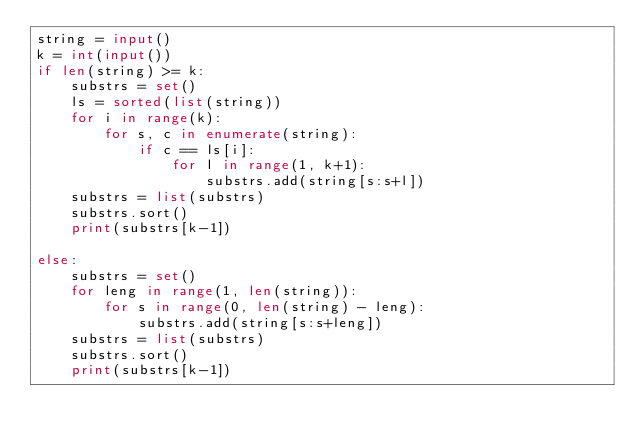Convert code to text. <code><loc_0><loc_0><loc_500><loc_500><_Python_>string = input()
k = int(input())
if len(string) >= k:
    substrs = set()
    ls = sorted(list(string))
    for i in range(k):
        for s, c in enumerate(string):
            if c == ls[i]:
                for l in range(1, k+1):
                    substrs.add(string[s:s+l])
    substrs = list(substrs)
    substrs.sort()
    print(substrs[k-1])

else:
    substrs = set()
    for leng in range(1, len(string)):
        for s in range(0, len(string) - leng):
            substrs.add(string[s:s+leng])
    substrs = list(substrs)
    substrs.sort()
    print(substrs[k-1])
</code> 